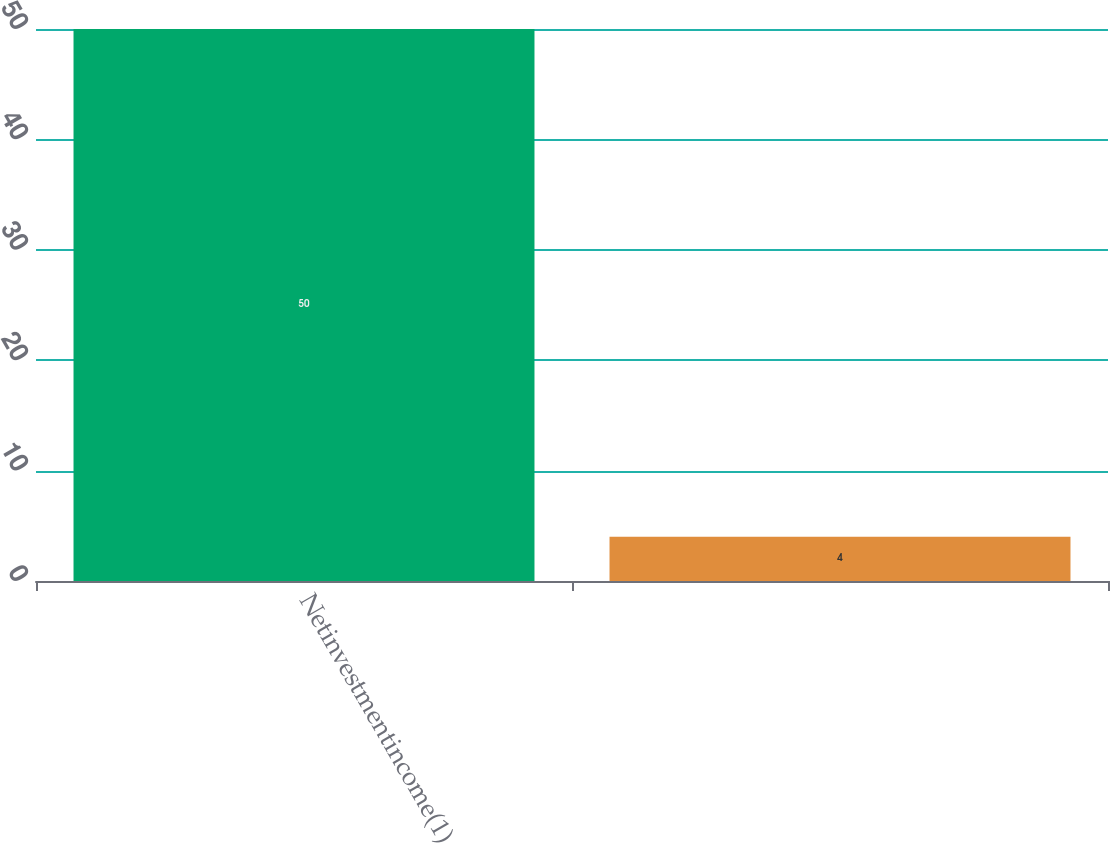Convert chart. <chart><loc_0><loc_0><loc_500><loc_500><bar_chart><fcel>Netinvestmentincome(1)<fcel>Unnamed: 1<nl><fcel>50<fcel>4<nl></chart> 